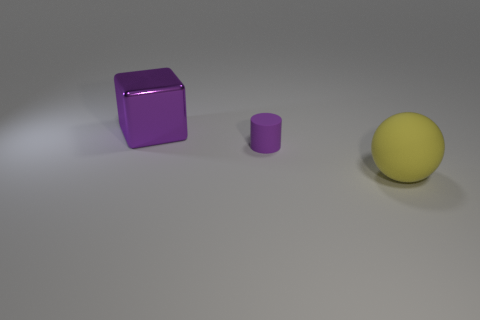Are there fewer tiny rubber cylinders that are on the left side of the big purple cube than tiny purple cylinders?
Make the answer very short. Yes. How many other objects are the same shape as the large matte thing?
Keep it short and to the point. 0. How many things are either objects that are on the right side of the shiny block or purple things that are to the left of the tiny purple cylinder?
Make the answer very short. 3. There is a thing that is both in front of the big purple object and to the left of the yellow rubber sphere; how big is it?
Offer a terse response. Small. There is a large thing that is behind the big yellow object; is its shape the same as the big yellow object?
Give a very brief answer. No. There is a purple thing that is right of the big thing behind the purple object that is on the right side of the big purple metallic block; what size is it?
Provide a succinct answer. Small. There is a cylinder that is the same color as the block; what size is it?
Provide a succinct answer. Small. What number of objects are either metal things or big yellow cubes?
Offer a terse response. 1. There is a thing that is both in front of the big purple cube and left of the rubber sphere; what shape is it?
Offer a terse response. Cylinder. Is the shape of the large yellow matte object the same as the large thing behind the large yellow rubber ball?
Your answer should be very brief. No. 